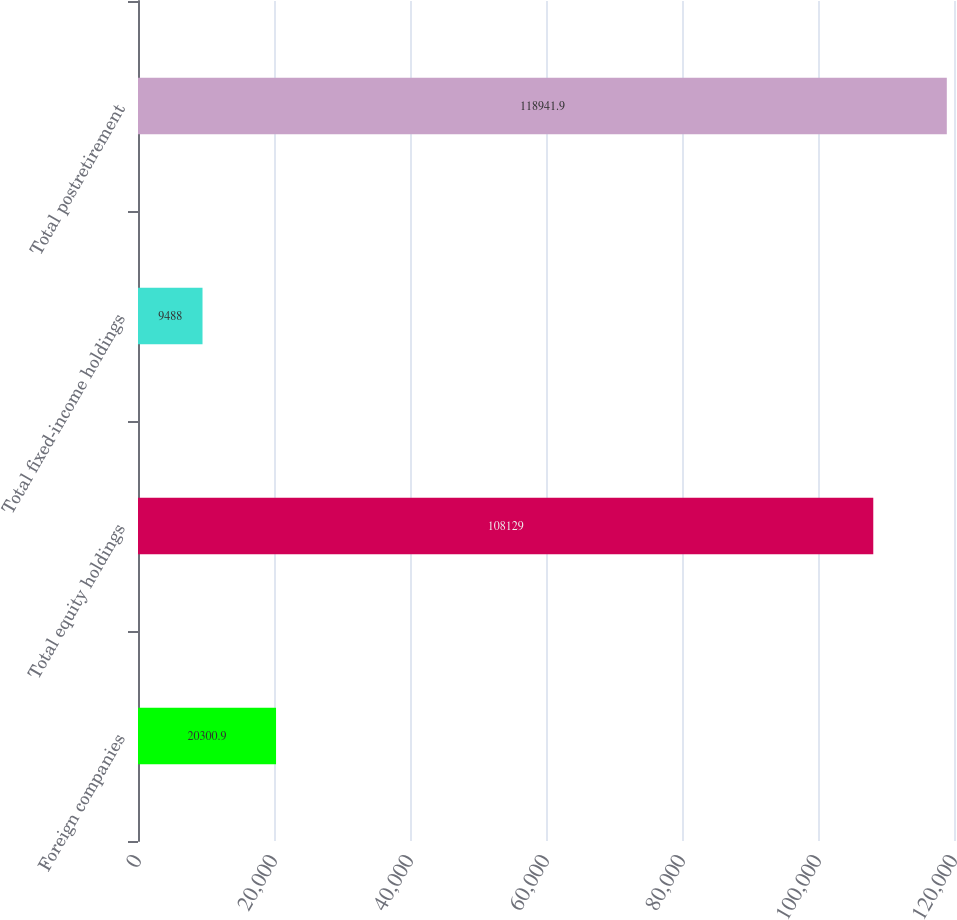Convert chart. <chart><loc_0><loc_0><loc_500><loc_500><bar_chart><fcel>Foreign companies<fcel>Total equity holdings<fcel>Total fixed-income holdings<fcel>Total postretirement<nl><fcel>20300.9<fcel>108129<fcel>9488<fcel>118942<nl></chart> 